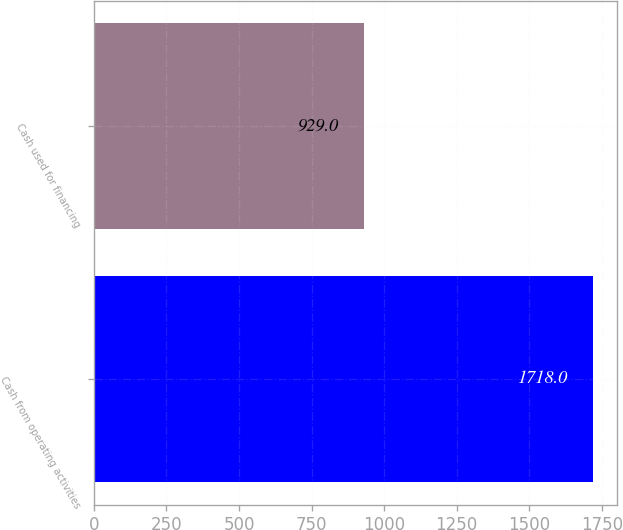Convert chart. <chart><loc_0><loc_0><loc_500><loc_500><bar_chart><fcel>Cash from operating activities<fcel>Cash used for financing<nl><fcel>1718<fcel>929<nl></chart> 